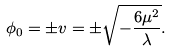<formula> <loc_0><loc_0><loc_500><loc_500>\phi _ { 0 } = \pm v = \pm \sqrt { - \frac { 6 \mu ^ { 2 } } { \lambda } } .</formula> 